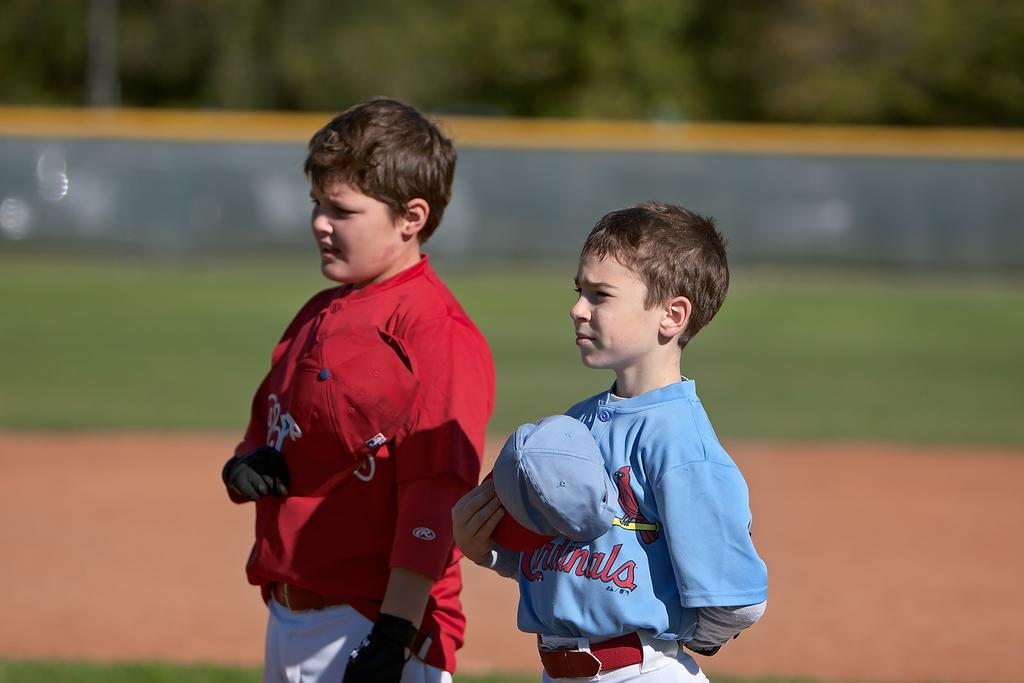Provide a one-sentence caption for the provided image. A young boy wears a light blue shirt with Cardinals on the front. 